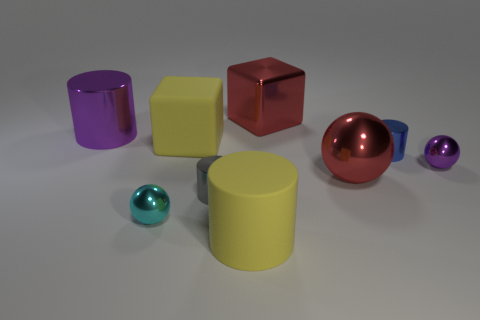There is a red thing behind the large shiny thing left of the big red metal thing behind the big purple object; what is it made of?
Keep it short and to the point. Metal. Are there the same number of matte blocks on the right side of the rubber cylinder and brown rubber objects?
Make the answer very short. Yes. Are there any other things that are the same size as the gray thing?
Give a very brief answer. Yes. How many things are purple metal cylinders or blue objects?
Offer a terse response. 2. What shape is the small gray object that is the same material as the small cyan object?
Provide a short and direct response. Cylinder. What is the size of the purple thing behind the tiny shiny sphere that is on the right side of the blue shiny object?
Provide a succinct answer. Large. What number of tiny objects are either yellow things or purple balls?
Make the answer very short. 1. How many other objects are there of the same color as the large sphere?
Make the answer very short. 1. There is a yellow matte object in front of the red metallic sphere; is it the same size as the ball that is on the left side of the red block?
Your answer should be compact. No. Does the large red sphere have the same material as the purple thing that is in front of the purple cylinder?
Provide a short and direct response. Yes. 